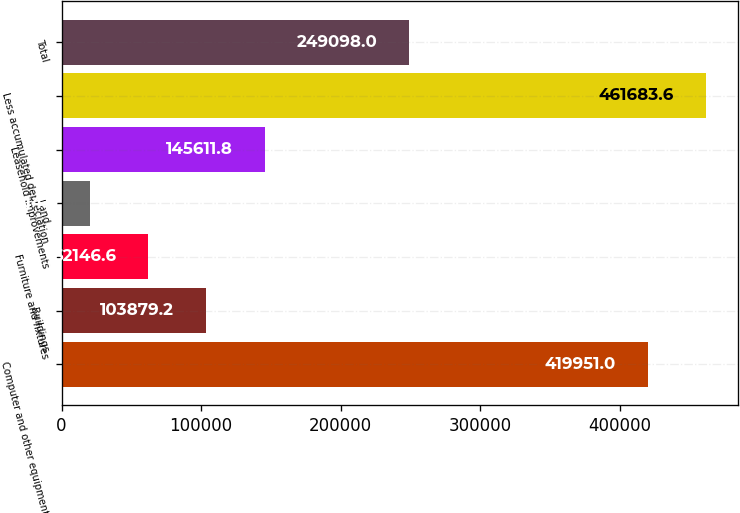Convert chart to OTSL. <chart><loc_0><loc_0><loc_500><loc_500><bar_chart><fcel>Computer and other equipment<fcel>Buildings<fcel>Furniture and fixtures<fcel>Land<fcel>Leasehold improvements<fcel>Less accumulated depreciation<fcel>Total<nl><fcel>419951<fcel>103879<fcel>62146.6<fcel>20414<fcel>145612<fcel>461684<fcel>249098<nl></chart> 